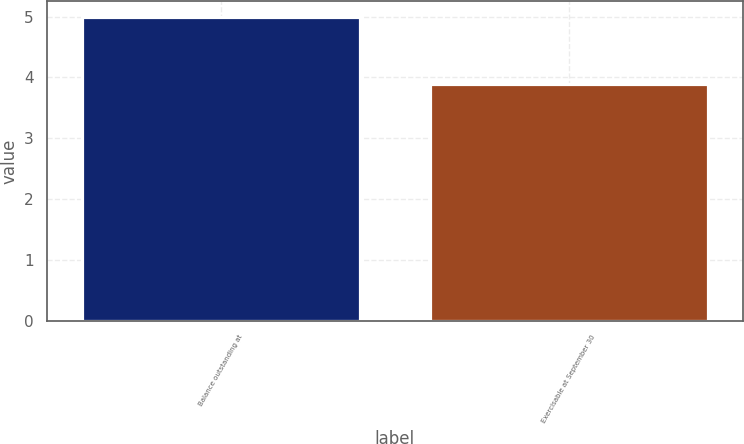Convert chart. <chart><loc_0><loc_0><loc_500><loc_500><bar_chart><fcel>Balance outstanding at<fcel>Exercisable at September 30<nl><fcel>5<fcel>3.9<nl></chart> 